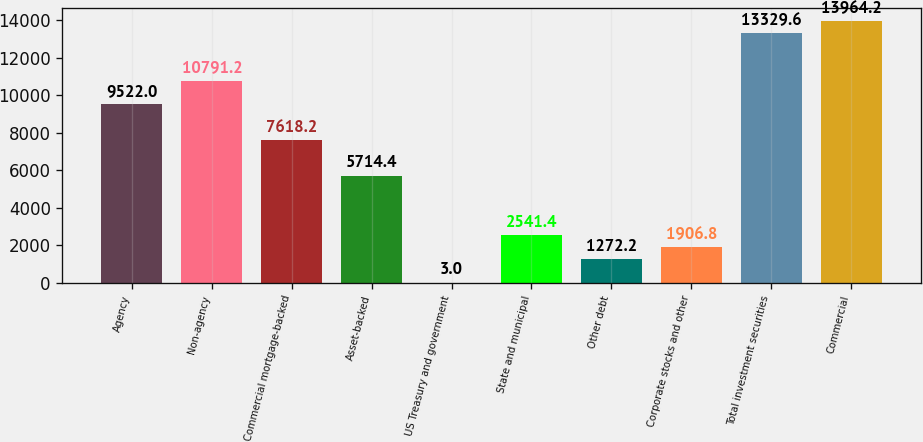<chart> <loc_0><loc_0><loc_500><loc_500><bar_chart><fcel>Agency<fcel>Non-agency<fcel>Commercial mortgage-backed<fcel>Asset-backed<fcel>US Treasury and government<fcel>State and municipal<fcel>Other debt<fcel>Corporate stocks and other<fcel>Total investment securities<fcel>Commercial<nl><fcel>9522<fcel>10791.2<fcel>7618.2<fcel>5714.4<fcel>3<fcel>2541.4<fcel>1272.2<fcel>1906.8<fcel>13329.6<fcel>13964.2<nl></chart> 